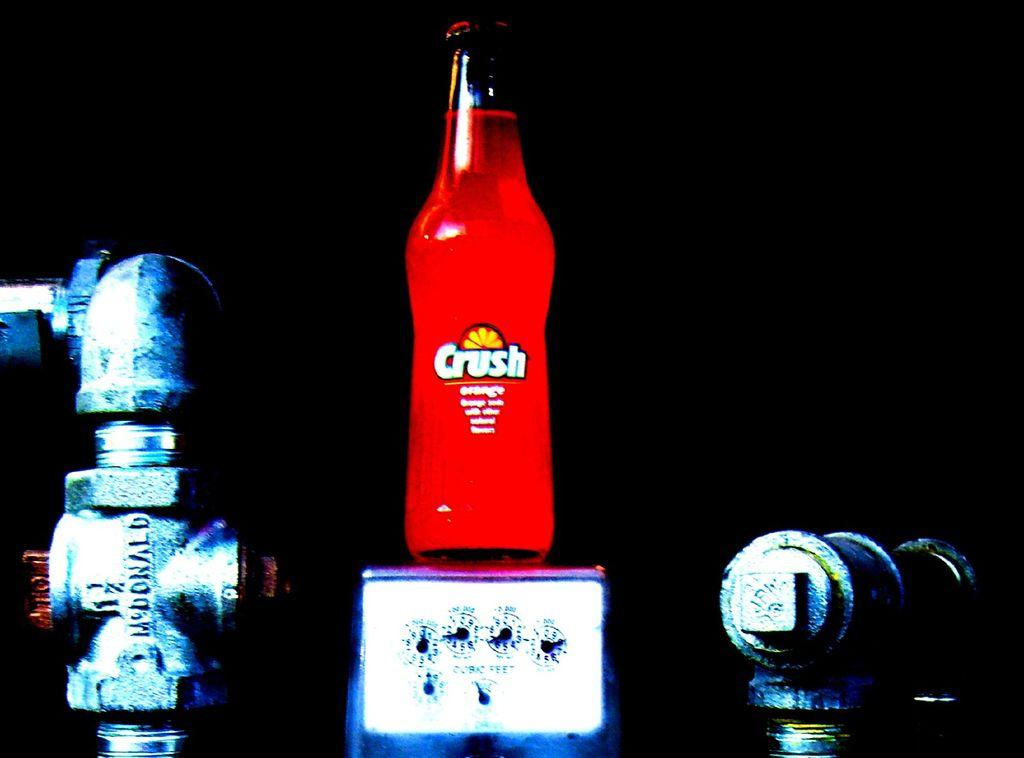Provide a one-sentence caption for the provided image. A bottle of orange crush stands on top of a scale being weighed. 